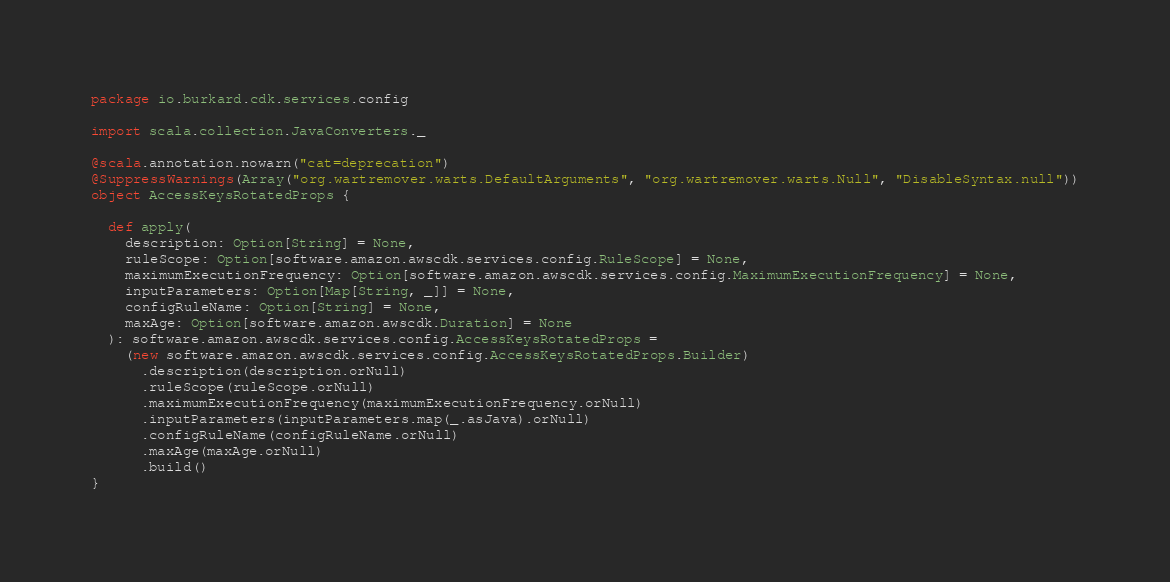<code> <loc_0><loc_0><loc_500><loc_500><_Scala_>package io.burkard.cdk.services.config

import scala.collection.JavaConverters._

@scala.annotation.nowarn("cat=deprecation")
@SuppressWarnings(Array("org.wartremover.warts.DefaultArguments", "org.wartremover.warts.Null", "DisableSyntax.null"))
object AccessKeysRotatedProps {

  def apply(
    description: Option[String] = None,
    ruleScope: Option[software.amazon.awscdk.services.config.RuleScope] = None,
    maximumExecutionFrequency: Option[software.amazon.awscdk.services.config.MaximumExecutionFrequency] = None,
    inputParameters: Option[Map[String, _]] = None,
    configRuleName: Option[String] = None,
    maxAge: Option[software.amazon.awscdk.Duration] = None
  ): software.amazon.awscdk.services.config.AccessKeysRotatedProps =
    (new software.amazon.awscdk.services.config.AccessKeysRotatedProps.Builder)
      .description(description.orNull)
      .ruleScope(ruleScope.orNull)
      .maximumExecutionFrequency(maximumExecutionFrequency.orNull)
      .inputParameters(inputParameters.map(_.asJava).orNull)
      .configRuleName(configRuleName.orNull)
      .maxAge(maxAge.orNull)
      .build()
}
</code> 